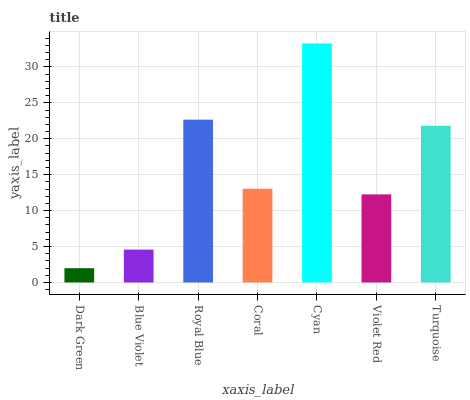Is Dark Green the minimum?
Answer yes or no. Yes. Is Cyan the maximum?
Answer yes or no. Yes. Is Blue Violet the minimum?
Answer yes or no. No. Is Blue Violet the maximum?
Answer yes or no. No. Is Blue Violet greater than Dark Green?
Answer yes or no. Yes. Is Dark Green less than Blue Violet?
Answer yes or no. Yes. Is Dark Green greater than Blue Violet?
Answer yes or no. No. Is Blue Violet less than Dark Green?
Answer yes or no. No. Is Coral the high median?
Answer yes or no. Yes. Is Coral the low median?
Answer yes or no. Yes. Is Turquoise the high median?
Answer yes or no. No. Is Blue Violet the low median?
Answer yes or no. No. 